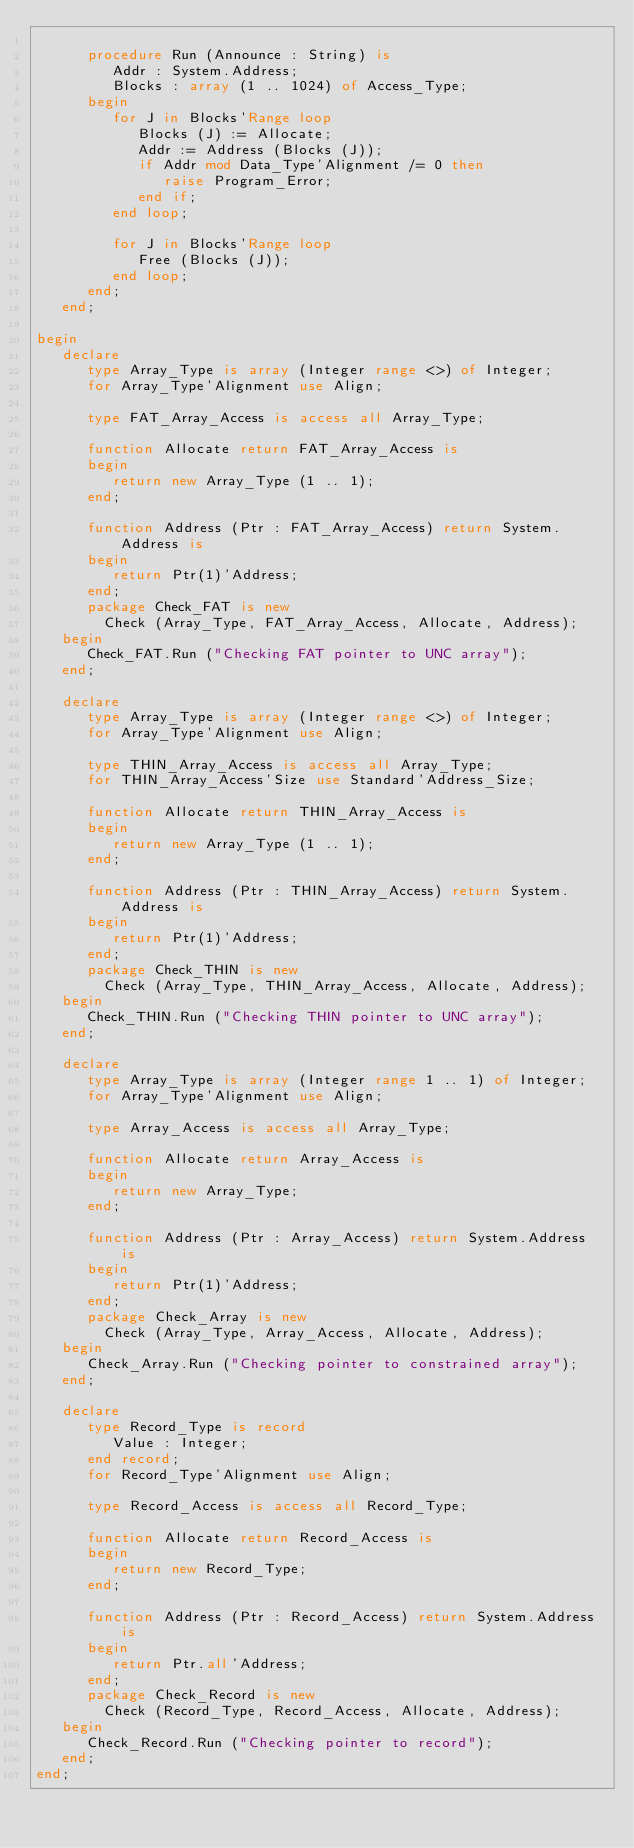<code> <loc_0><loc_0><loc_500><loc_500><_Ada_>
      procedure Run (Announce : String) is
         Addr : System.Address;
         Blocks : array (1 .. 1024) of Access_Type;
      begin
         for J in Blocks'Range loop
            Blocks (J) := Allocate;
            Addr := Address (Blocks (J));
            if Addr mod Data_Type'Alignment /= 0 then
               raise Program_Error;
            end if;
         end loop;

         for J in Blocks'Range loop
            Free (Blocks (J));
         end loop;
      end;
   end;

begin
   declare
      type Array_Type is array (Integer range <>) of Integer;
      for Array_Type'Alignment use Align;

      type FAT_Array_Access is access all Array_Type;

      function Allocate return FAT_Array_Access is
      begin
         return new Array_Type (1 .. 1);
      end;

      function Address (Ptr : FAT_Array_Access) return System.Address is
      begin
         return Ptr(1)'Address;
      end;
      package Check_FAT is new
        Check (Array_Type, FAT_Array_Access, Allocate, Address);
   begin
      Check_FAT.Run ("Checking FAT pointer to UNC array");
   end;

   declare
      type Array_Type is array (Integer range <>) of Integer;
      for Array_Type'Alignment use Align;

      type THIN_Array_Access is access all Array_Type;
      for THIN_Array_Access'Size use Standard'Address_Size;

      function Allocate return THIN_Array_Access is
      begin
         return new Array_Type (1 .. 1);
      end;

      function Address (Ptr : THIN_Array_Access) return System.Address is
      begin
         return Ptr(1)'Address;
      end;
      package Check_THIN is new
        Check (Array_Type, THIN_Array_Access, Allocate, Address);
   begin
      Check_THIN.Run ("Checking THIN pointer to UNC array");
   end;

   declare
      type Array_Type is array (Integer range 1 .. 1) of Integer;
      for Array_Type'Alignment use Align;

      type Array_Access is access all Array_Type;

      function Allocate return Array_Access is
      begin
         return new Array_Type;
      end;

      function Address (Ptr : Array_Access) return System.Address is
      begin
         return Ptr(1)'Address;
      end;
      package Check_Array is new
        Check (Array_Type, Array_Access, Allocate, Address);
   begin
      Check_Array.Run ("Checking pointer to constrained array");
   end;

   declare
      type Record_Type is record
         Value : Integer;
      end record;
      for Record_Type'Alignment use Align;

      type Record_Access is access all Record_Type;

      function Allocate return Record_Access is
      begin
         return new Record_Type;
      end;

      function Address (Ptr : Record_Access) return System.Address is
      begin
         return Ptr.all'Address;
      end;
      package Check_Record is new
        Check (Record_Type, Record_Access, Allocate, Address);
   begin
      Check_Record.Run ("Checking pointer to record");
   end;
end;

</code> 